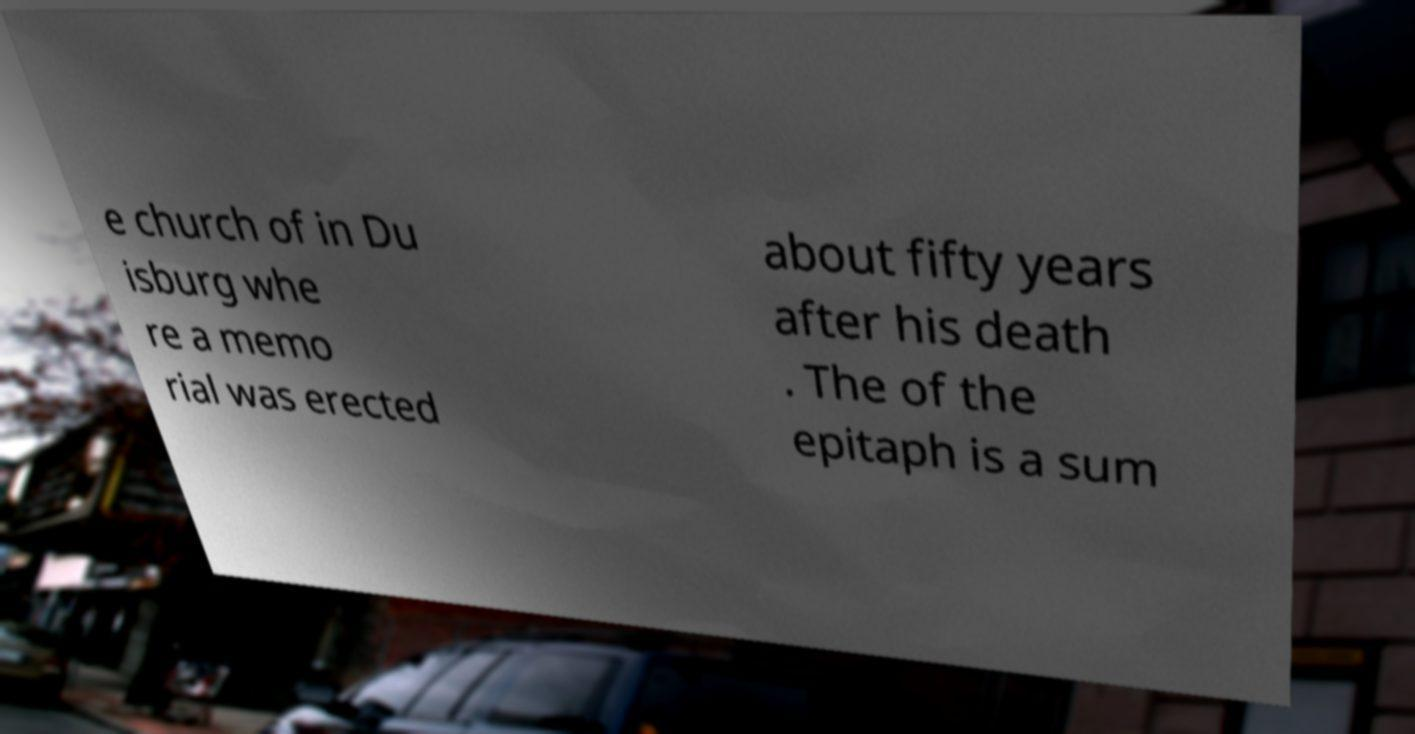There's text embedded in this image that I need extracted. Can you transcribe it verbatim? e church of in Du isburg whe re a memo rial was erected about fifty years after his death . The of the epitaph is a sum 